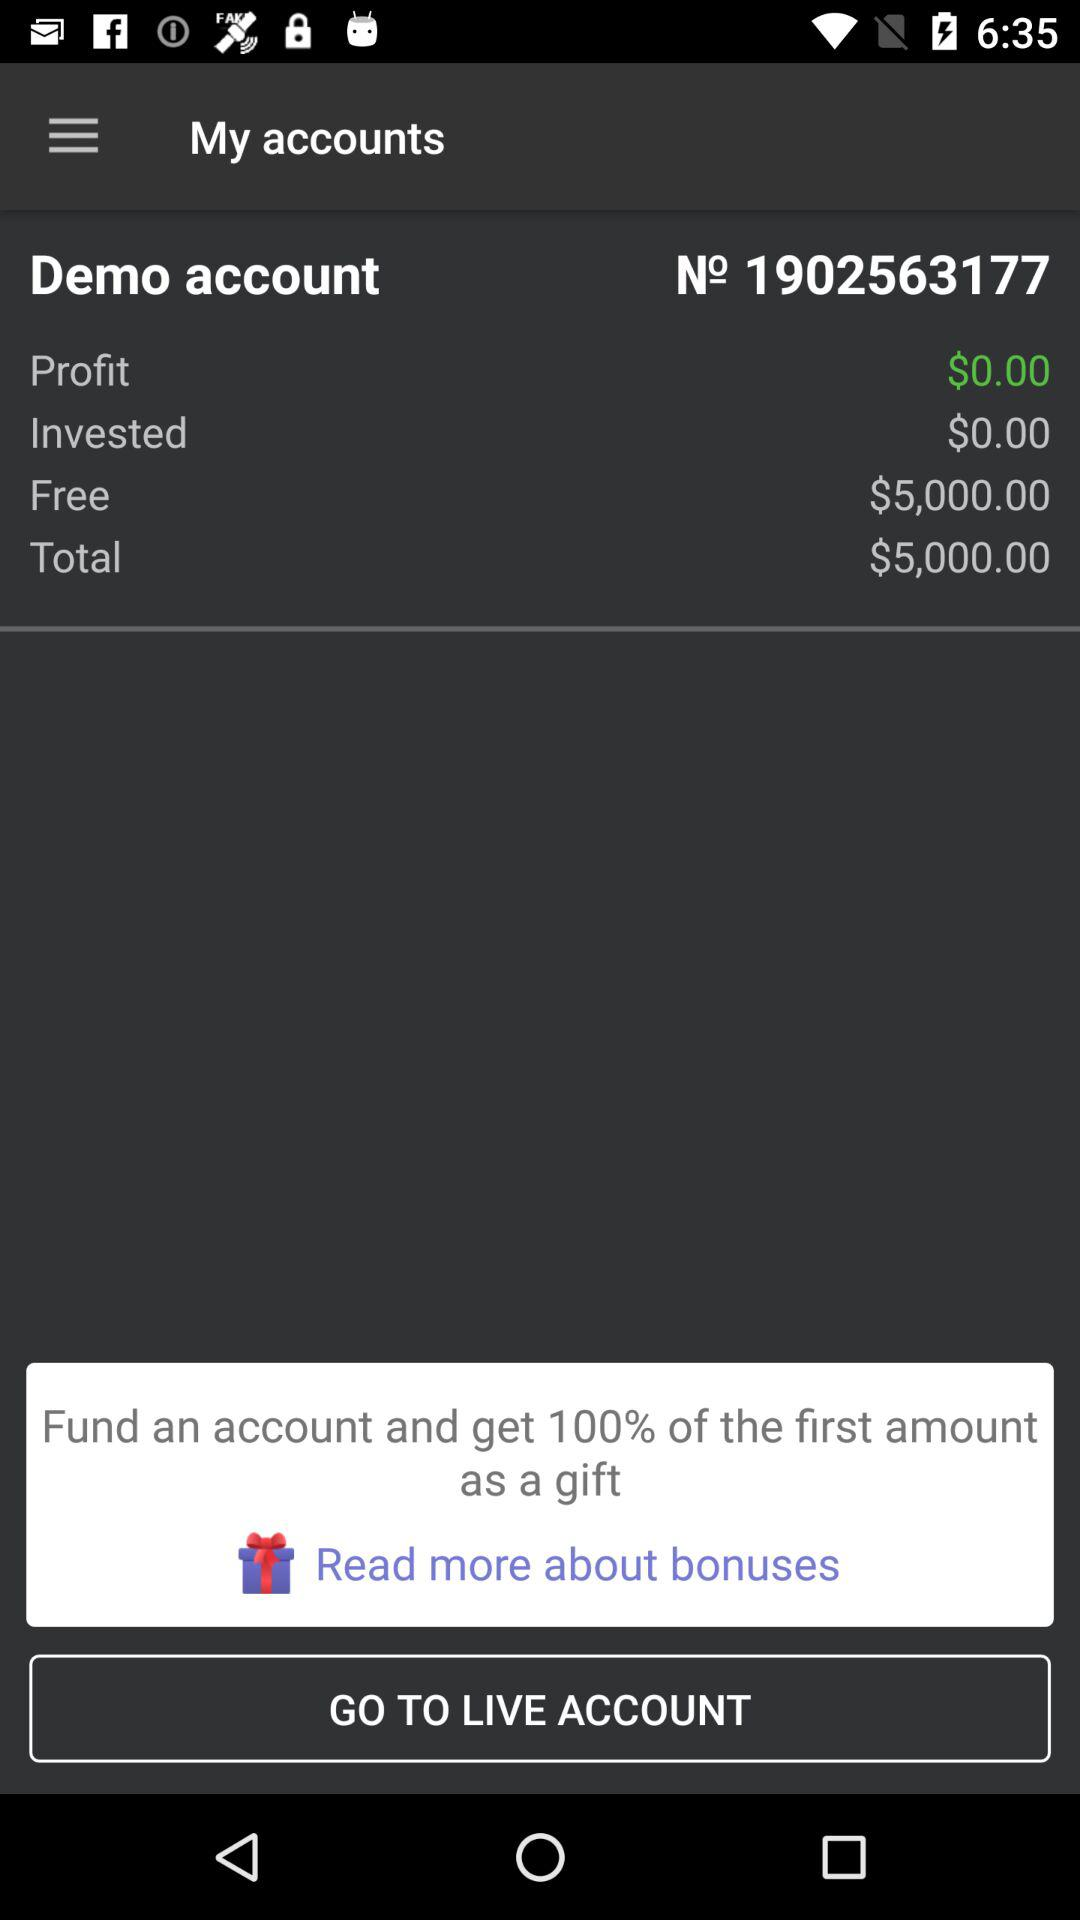What is the free amount? The free amount is $5,000.00. 